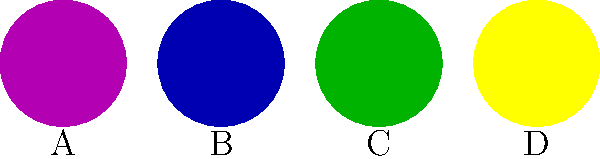As a criminal defense attorney preparing for a courtroom demonstration, you need to accurately represent the progression of a bruise over time. Based on the color diagram above, which bruise most likely represents an injury that is 5-7 days old? To answer this question, we need to understand the typical progression of bruise colors over time:

1. Fresh bruises (0-2 days) appear reddish-purple or blue.
2. After 1-2 days, bruises often turn a darker blue or purple.
3. Around 5-7 days, bruises begin to turn green as the hemoglobin breaks down.
4. Between 7-10 days, bruises typically appear yellow or brown as they continue to heal.

Analyzing the diagram:
A: Purple - represents a fresh bruise (0-2 days)
B: Blue - represents a 1-2 day old bruise
C: Green - represents a 5-7 day old bruise
D: Yellow - represents a 7-10 day old bruise

Therefore, the green bruise labeled C most accurately represents an injury that is 5-7 days old.
Answer: C 